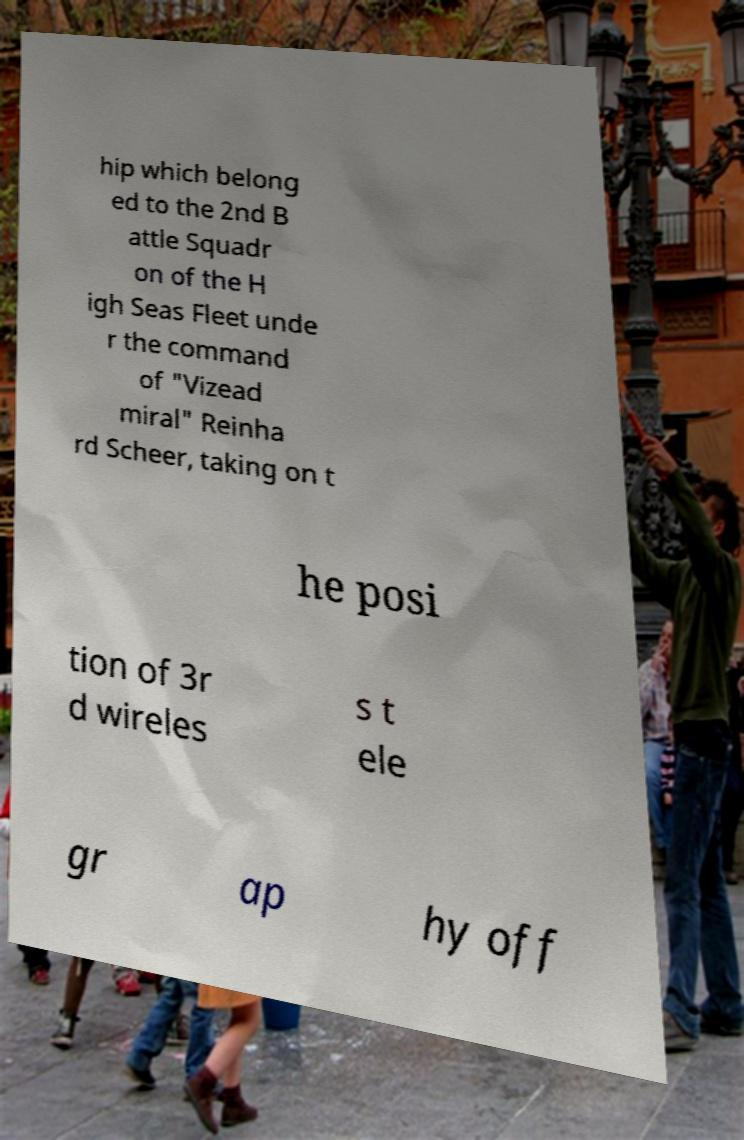Could you extract and type out the text from this image? hip which belong ed to the 2nd B attle Squadr on of the H igh Seas Fleet unde r the command of "Vizead miral" Reinha rd Scheer, taking on t he posi tion of 3r d wireles s t ele gr ap hy off 